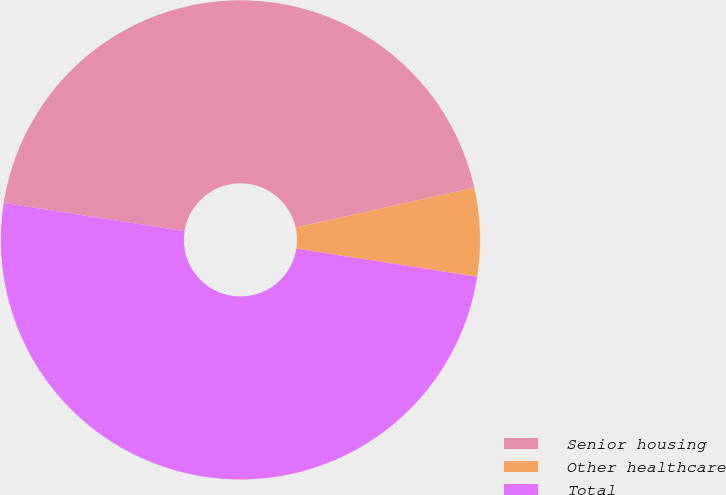<chart> <loc_0><loc_0><loc_500><loc_500><pie_chart><fcel>Senior housing<fcel>Other healthcare<fcel>Total<nl><fcel>44.04%<fcel>5.96%<fcel>50.0%<nl></chart> 